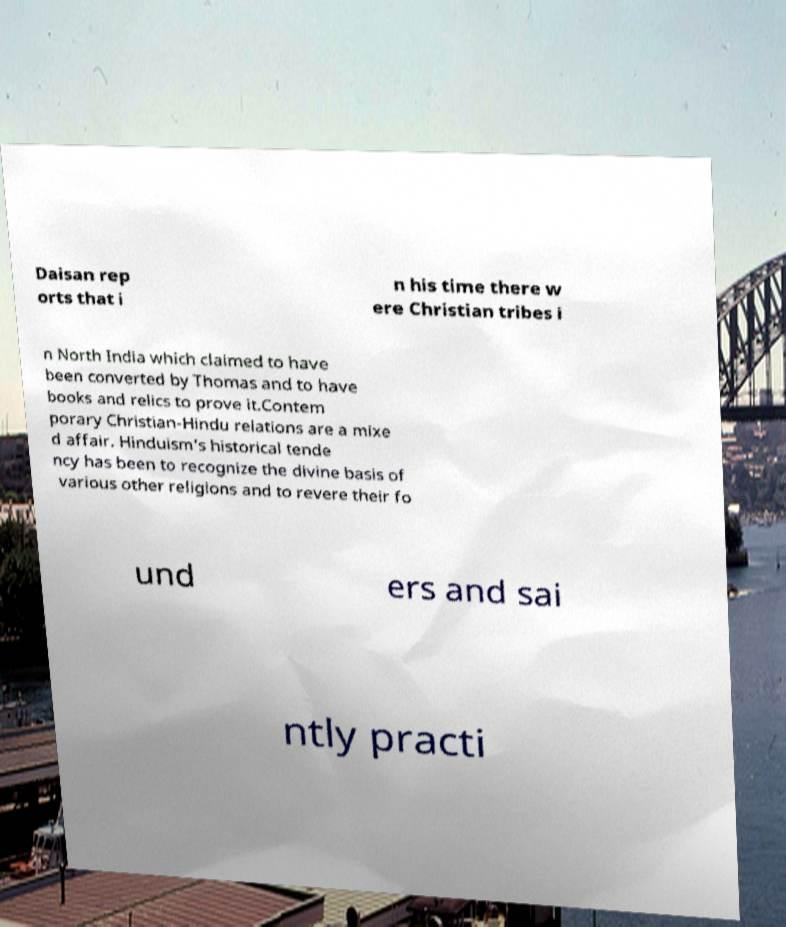Can you accurately transcribe the text from the provided image for me? Daisan rep orts that i n his time there w ere Christian tribes i n North India which claimed to have been converted by Thomas and to have books and relics to prove it.Contem porary Christian-Hindu relations are a mixe d affair. Hinduism's historical tende ncy has been to recognize the divine basis of various other religions and to revere their fo und ers and sai ntly practi 